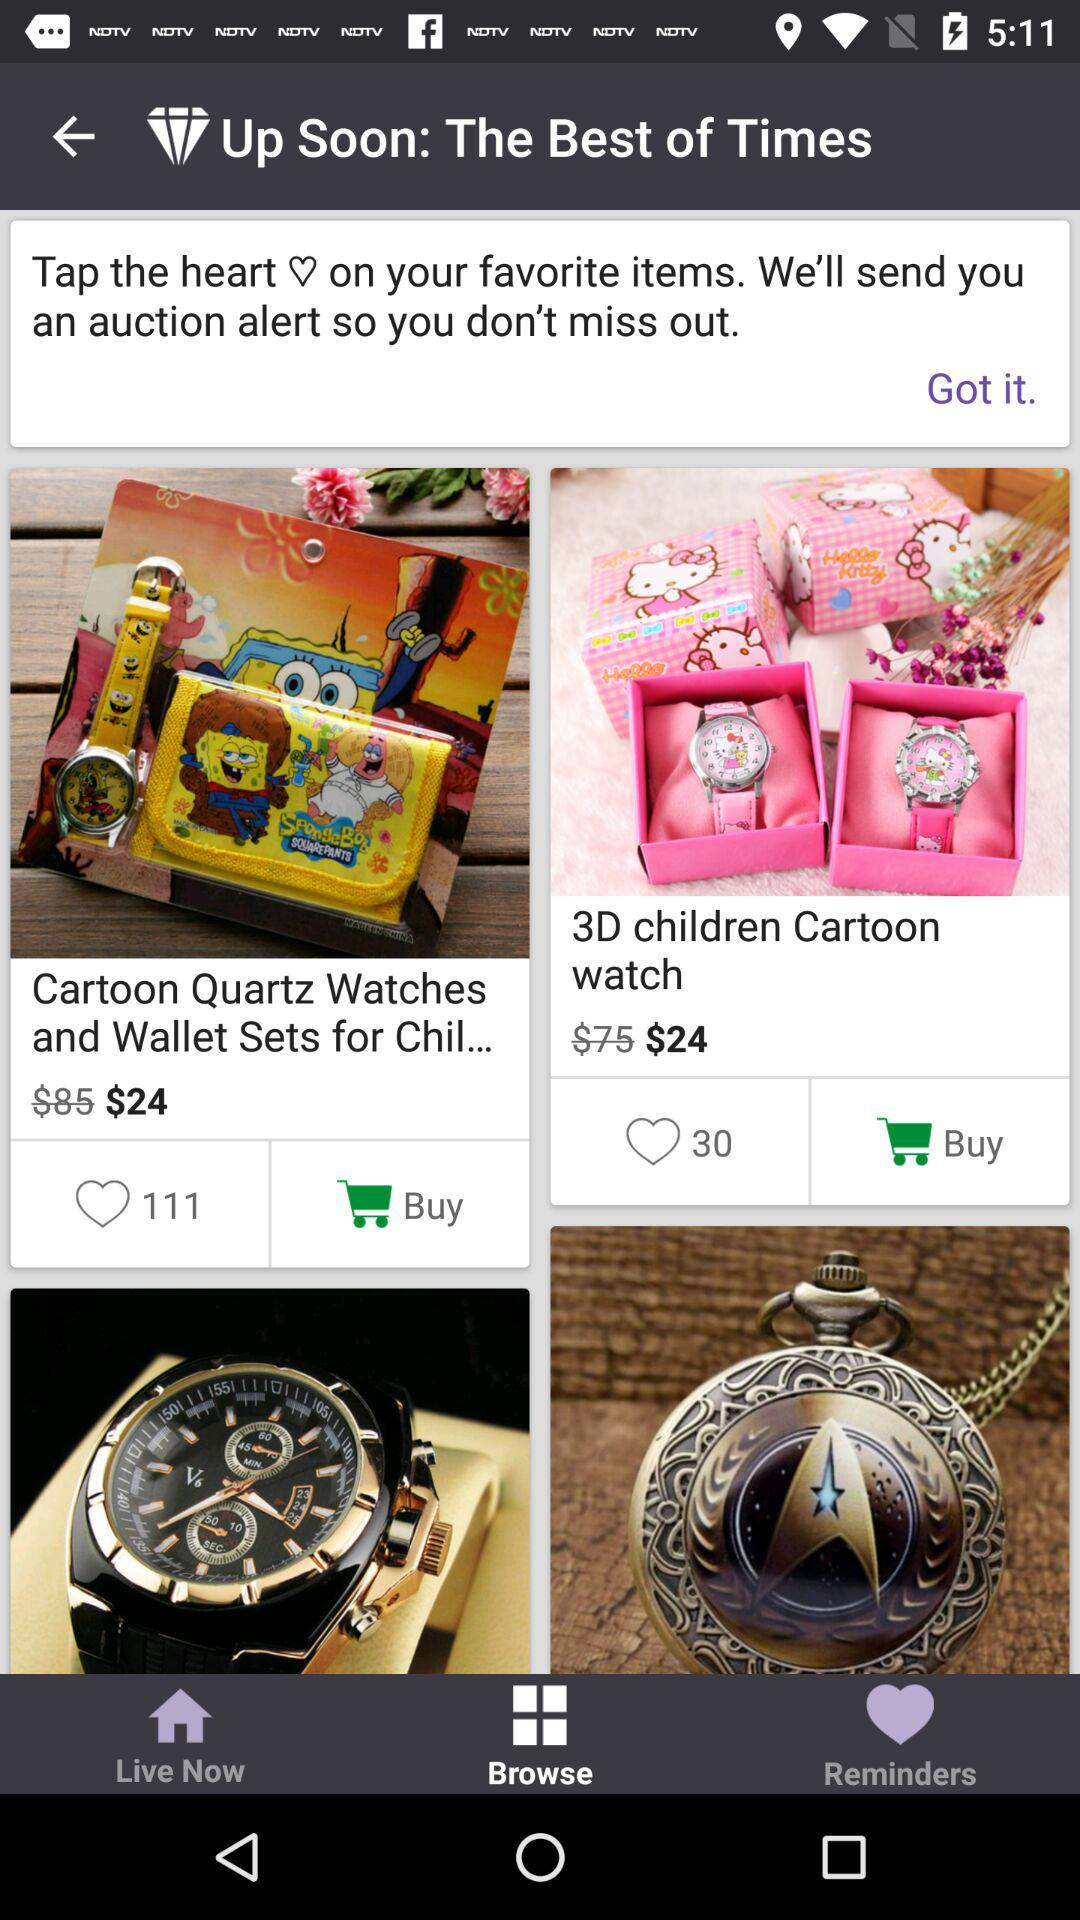How many items have a heart next to them?
Answer the question using a single word or phrase. 2 